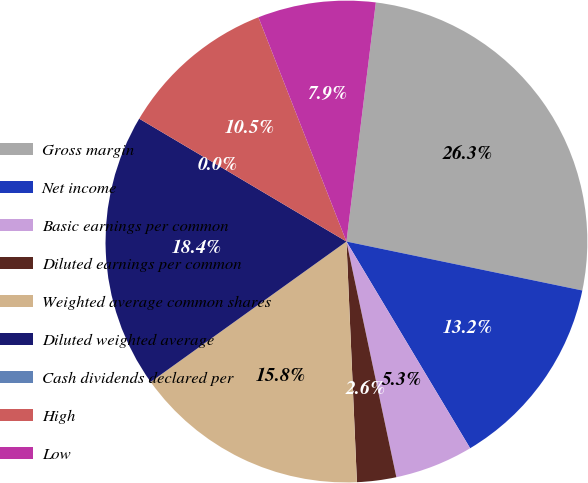Convert chart. <chart><loc_0><loc_0><loc_500><loc_500><pie_chart><fcel>Gross margin<fcel>Net income<fcel>Basic earnings per common<fcel>Diluted earnings per common<fcel>Weighted average common shares<fcel>Diluted weighted average<fcel>Cash dividends declared per<fcel>High<fcel>Low<nl><fcel>26.31%<fcel>13.16%<fcel>5.26%<fcel>2.63%<fcel>15.79%<fcel>18.42%<fcel>0.0%<fcel>10.53%<fcel>7.9%<nl></chart> 